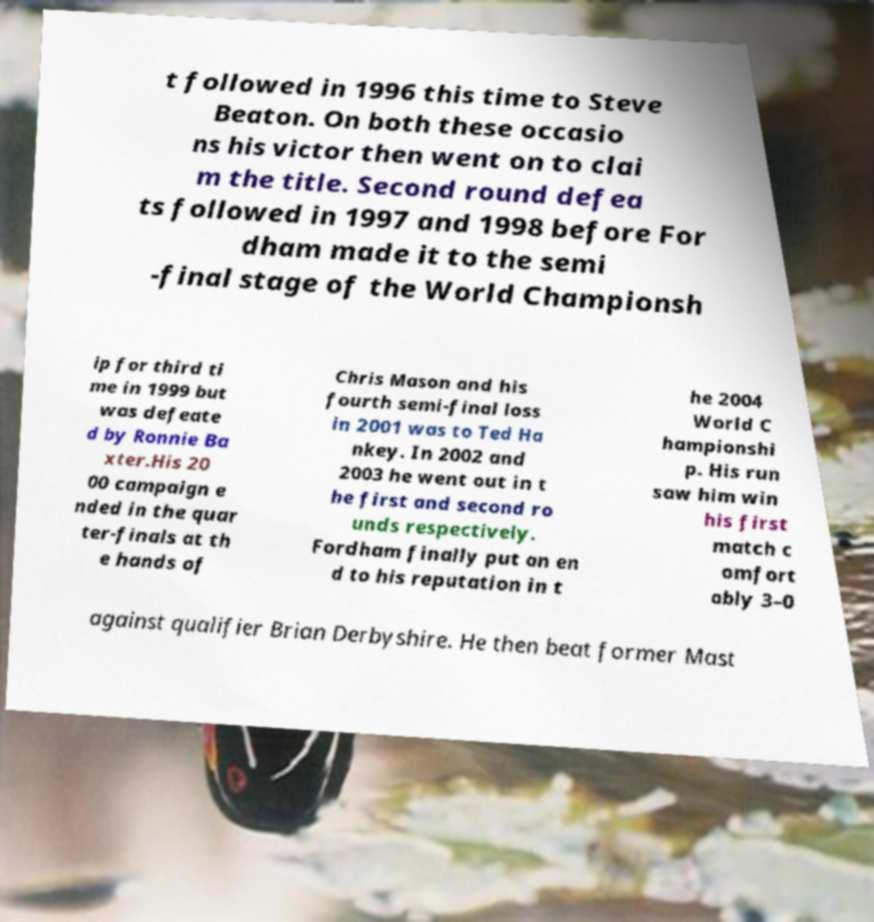Could you extract and type out the text from this image? t followed in 1996 this time to Steve Beaton. On both these occasio ns his victor then went on to clai m the title. Second round defea ts followed in 1997 and 1998 before For dham made it to the semi -final stage of the World Championsh ip for third ti me in 1999 but was defeate d by Ronnie Ba xter.His 20 00 campaign e nded in the quar ter-finals at th e hands of Chris Mason and his fourth semi-final loss in 2001 was to Ted Ha nkey. In 2002 and 2003 he went out in t he first and second ro unds respectively. Fordham finally put an en d to his reputation in t he 2004 World C hampionshi p. His run saw him win his first match c omfort ably 3–0 against qualifier Brian Derbyshire. He then beat former Mast 